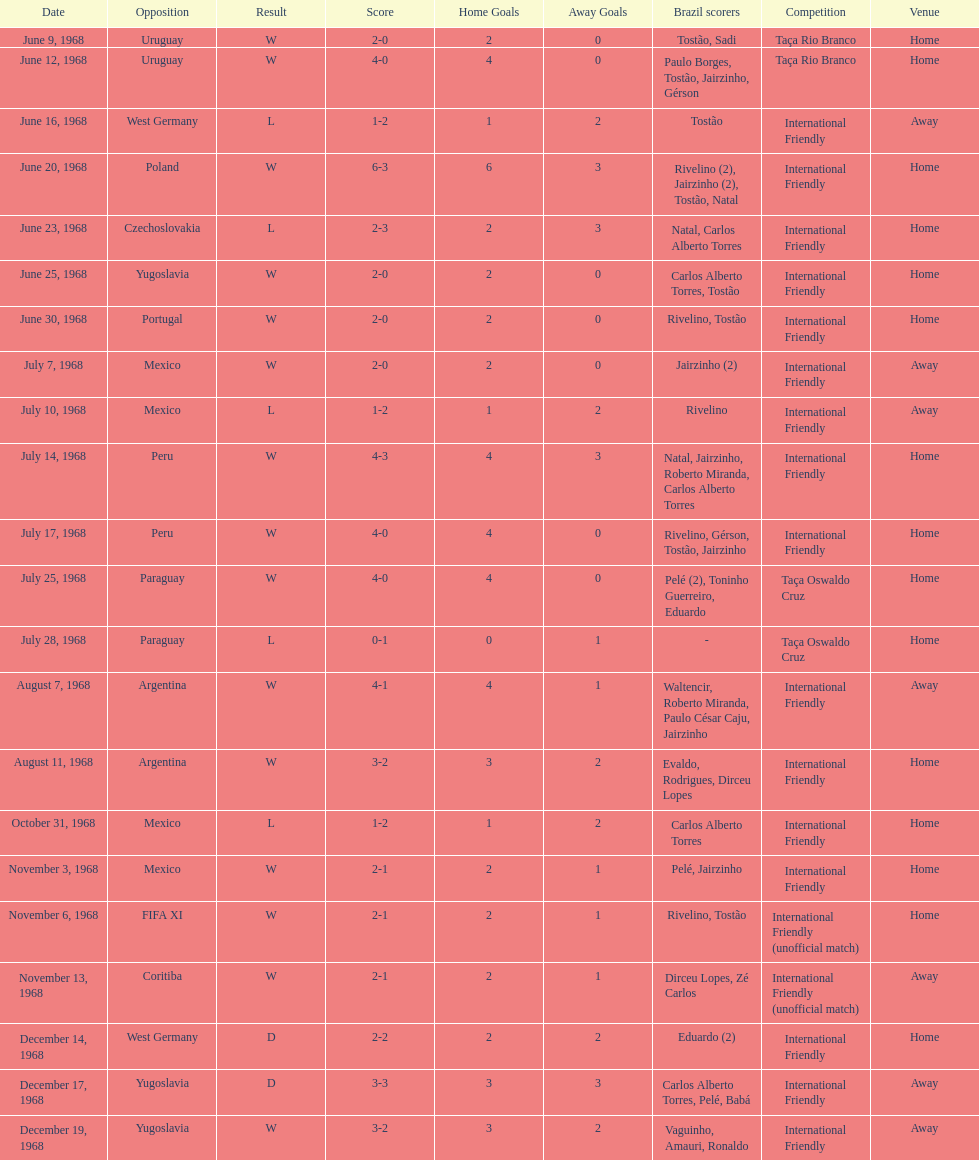How many matches are wins? 15. 